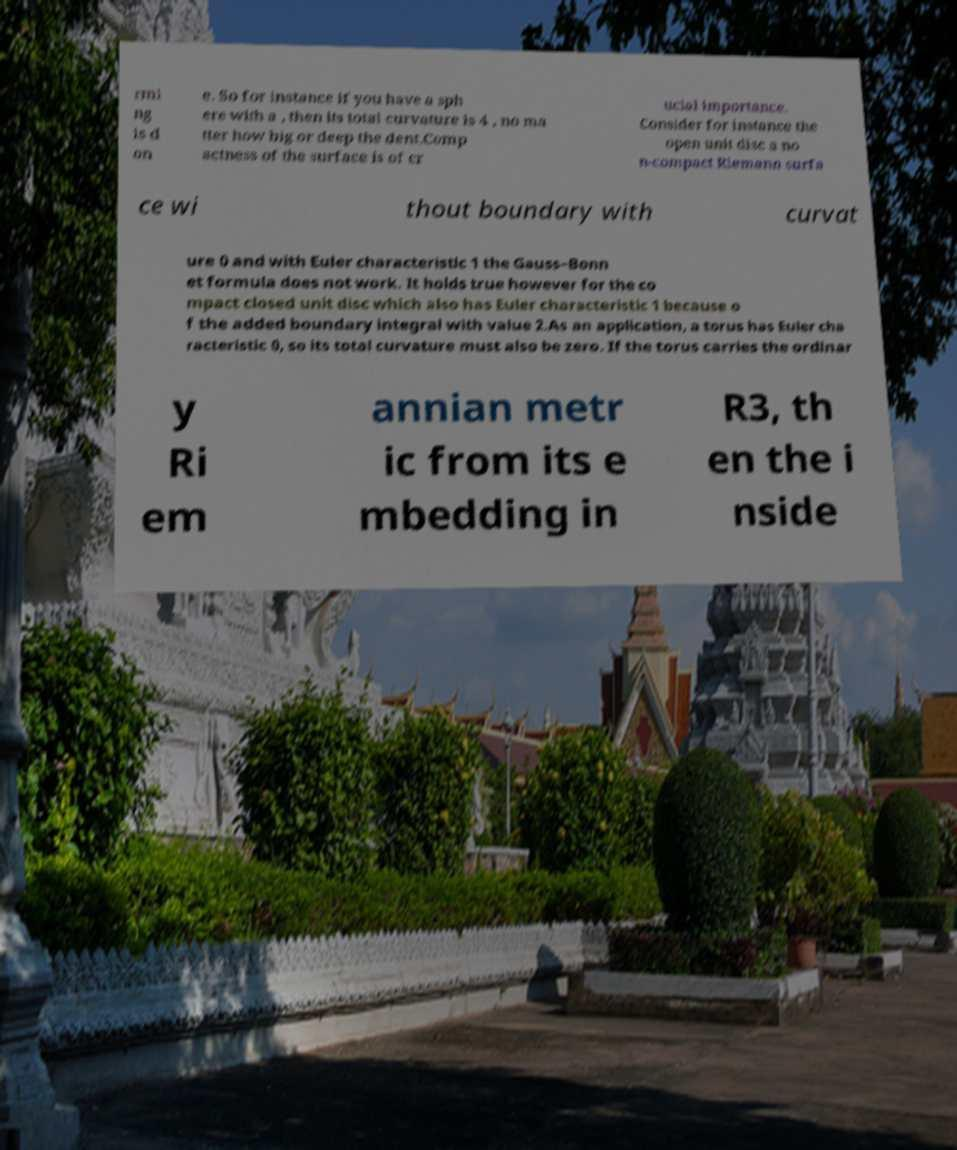Can you accurately transcribe the text from the provided image for me? rmi ng is d on e. So for instance if you have a sph ere with a , then its total curvature is 4 , no ma tter how big or deep the dent.Comp actness of the surface is of cr ucial importance. Consider for instance the open unit disc a no n-compact Riemann surfa ce wi thout boundary with curvat ure 0 and with Euler characteristic 1 the Gauss–Bonn et formula does not work. It holds true however for the co mpact closed unit disc which also has Euler characteristic 1 because o f the added boundary integral with value 2.As an application, a torus has Euler cha racteristic 0, so its total curvature must also be zero. If the torus carries the ordinar y Ri em annian metr ic from its e mbedding in R3, th en the i nside 